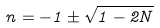<formula> <loc_0><loc_0><loc_500><loc_500>n = - 1 \pm \sqrt { 1 - 2 N }</formula> 